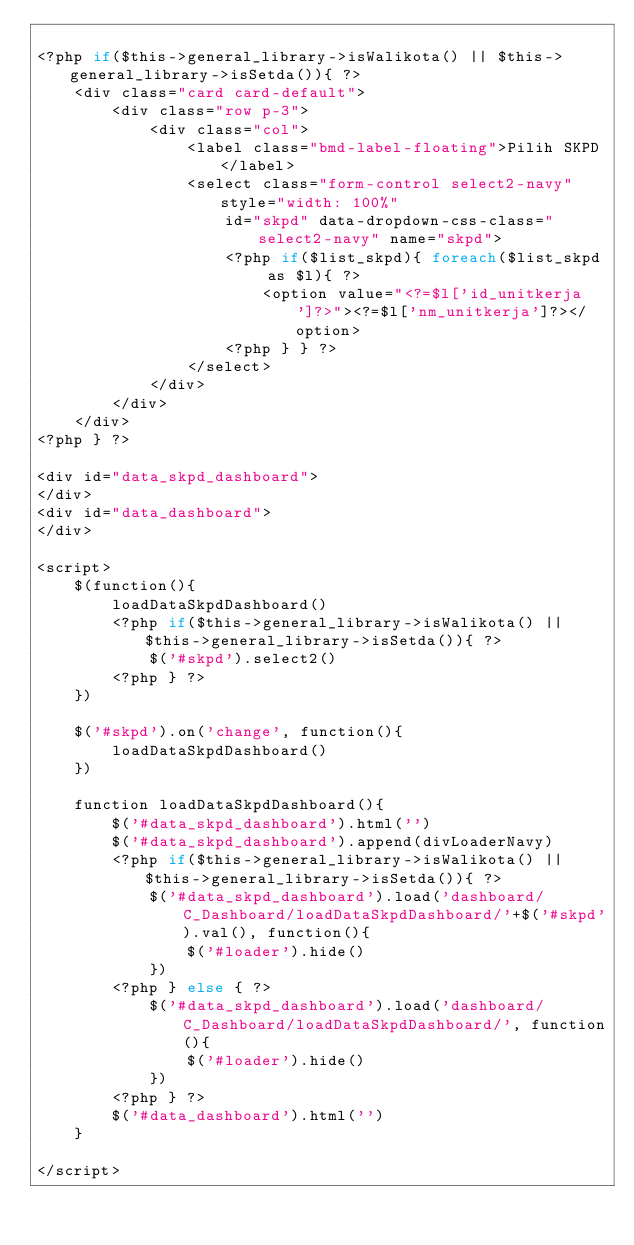<code> <loc_0><loc_0><loc_500><loc_500><_PHP_>
<?php if($this->general_library->isWalikota() || $this->general_library->isSetda()){ ?>
    <div class="card card-default">
        <div class="row p-3">
            <div class="col">
                <label class="bmd-label-floating">Pilih SKPD</label>
                <select class="form-control select2-navy" style="width: 100%"
                    id="skpd" data-dropdown-css-class="select2-navy" name="skpd">
                    <?php if($list_skpd){ foreach($list_skpd as $l){ ?>
                        <option value="<?=$l['id_unitkerja']?>"><?=$l['nm_unitkerja']?></option>
                    <?php } } ?>
                </select>
            </div>
        </div>
    </div>
<?php } ?>

<div id="data_skpd_dashboard">
</div>
<div id="data_dashboard">
</div>

<script>
    $(function(){
        loadDataSkpdDashboard()
        <?php if($this->general_library->isWalikota() || $this->general_library->isSetda()){ ?>
            $('#skpd').select2()
        <?php } ?>
    })

    $('#skpd').on('change', function(){
        loadDataSkpdDashboard()
    })

    function loadDataSkpdDashboard(){
        $('#data_skpd_dashboard').html('')
        $('#data_skpd_dashboard').append(divLoaderNavy)
        <?php if($this->general_library->isWalikota() || $this->general_library->isSetda()){ ?>
            $('#data_skpd_dashboard').load('dashboard/C_Dashboard/loadDataSkpdDashboard/'+$('#skpd').val(), function(){
                $('#loader').hide()
            })
        <?php } else { ?>
            $('#data_skpd_dashboard').load('dashboard/C_Dashboard/loadDataSkpdDashboard/', function(){
                $('#loader').hide()
            })
        <?php } ?>
        $('#data_dashboard').html('')
    }

</script></code> 